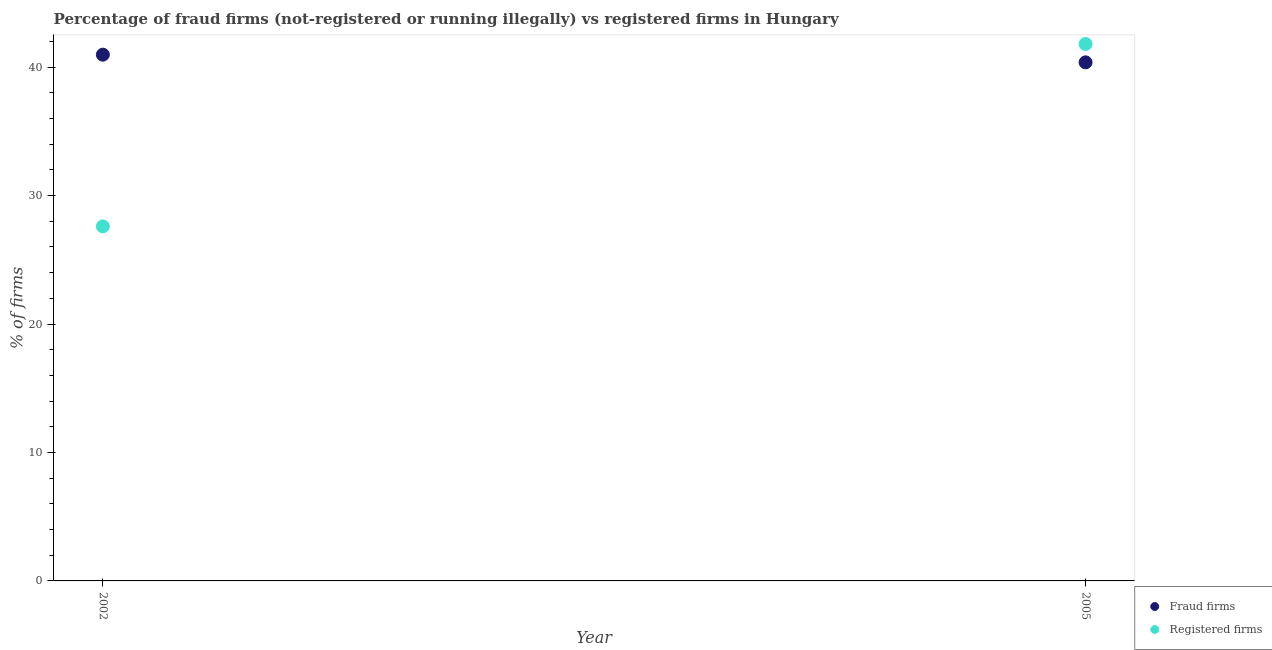Is the number of dotlines equal to the number of legend labels?
Keep it short and to the point. Yes. What is the percentage of fraud firms in 2005?
Provide a succinct answer. 40.37. Across all years, what is the maximum percentage of fraud firms?
Provide a short and direct response. 40.97. Across all years, what is the minimum percentage of registered firms?
Provide a short and direct response. 27.6. In which year was the percentage of fraud firms maximum?
Your answer should be very brief. 2002. In which year was the percentage of fraud firms minimum?
Keep it short and to the point. 2005. What is the total percentage of registered firms in the graph?
Make the answer very short. 69.4. What is the difference between the percentage of fraud firms in 2002 and that in 2005?
Your response must be concise. 0.6. What is the difference between the percentage of fraud firms in 2002 and the percentage of registered firms in 2005?
Your answer should be compact. -0.83. What is the average percentage of fraud firms per year?
Make the answer very short. 40.67. In the year 2002, what is the difference between the percentage of registered firms and percentage of fraud firms?
Your answer should be very brief. -13.37. What is the ratio of the percentage of registered firms in 2002 to that in 2005?
Provide a succinct answer. 0.66. Does the graph contain grids?
Keep it short and to the point. No. Where does the legend appear in the graph?
Offer a terse response. Bottom right. How are the legend labels stacked?
Provide a short and direct response. Vertical. What is the title of the graph?
Your answer should be compact. Percentage of fraud firms (not-registered or running illegally) vs registered firms in Hungary. Does "Resident workers" appear as one of the legend labels in the graph?
Give a very brief answer. No. What is the label or title of the X-axis?
Offer a very short reply. Year. What is the label or title of the Y-axis?
Give a very brief answer. % of firms. What is the % of firms of Fraud firms in 2002?
Make the answer very short. 40.97. What is the % of firms in Registered firms in 2002?
Make the answer very short. 27.6. What is the % of firms in Fraud firms in 2005?
Ensure brevity in your answer.  40.37. What is the % of firms in Registered firms in 2005?
Make the answer very short. 41.8. Across all years, what is the maximum % of firms in Fraud firms?
Ensure brevity in your answer.  40.97. Across all years, what is the maximum % of firms in Registered firms?
Offer a very short reply. 41.8. Across all years, what is the minimum % of firms in Fraud firms?
Your answer should be compact. 40.37. Across all years, what is the minimum % of firms in Registered firms?
Your response must be concise. 27.6. What is the total % of firms of Fraud firms in the graph?
Give a very brief answer. 81.34. What is the total % of firms in Registered firms in the graph?
Make the answer very short. 69.4. What is the difference between the % of firms of Fraud firms in 2002 and that in 2005?
Provide a short and direct response. 0.6. What is the difference between the % of firms in Registered firms in 2002 and that in 2005?
Provide a short and direct response. -14.2. What is the difference between the % of firms in Fraud firms in 2002 and the % of firms in Registered firms in 2005?
Your answer should be very brief. -0.83. What is the average % of firms of Fraud firms per year?
Provide a short and direct response. 40.67. What is the average % of firms of Registered firms per year?
Keep it short and to the point. 34.7. In the year 2002, what is the difference between the % of firms in Fraud firms and % of firms in Registered firms?
Your answer should be very brief. 13.37. In the year 2005, what is the difference between the % of firms of Fraud firms and % of firms of Registered firms?
Ensure brevity in your answer.  -1.43. What is the ratio of the % of firms in Fraud firms in 2002 to that in 2005?
Provide a short and direct response. 1.01. What is the ratio of the % of firms of Registered firms in 2002 to that in 2005?
Ensure brevity in your answer.  0.66. What is the difference between the highest and the second highest % of firms of Fraud firms?
Your answer should be compact. 0.6. What is the difference between the highest and the second highest % of firms in Registered firms?
Make the answer very short. 14.2. 